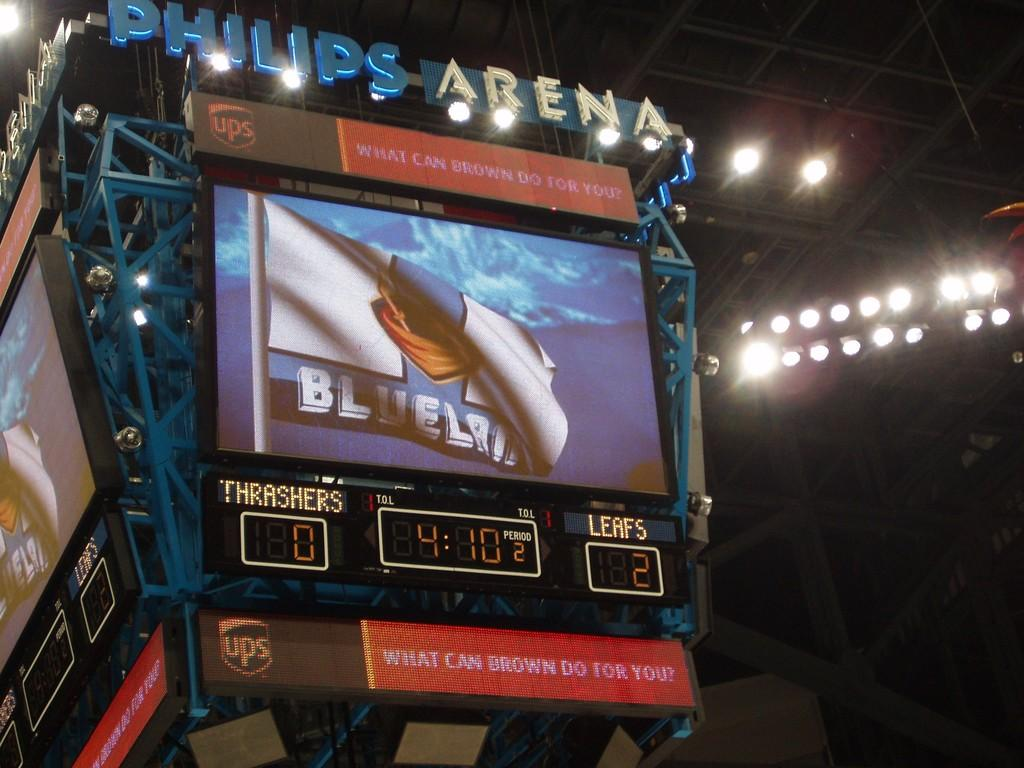<image>
Give a short and clear explanation of the subsequent image. The Leafs are beating the Thrashers 2 to 0 in the 2nd period. 